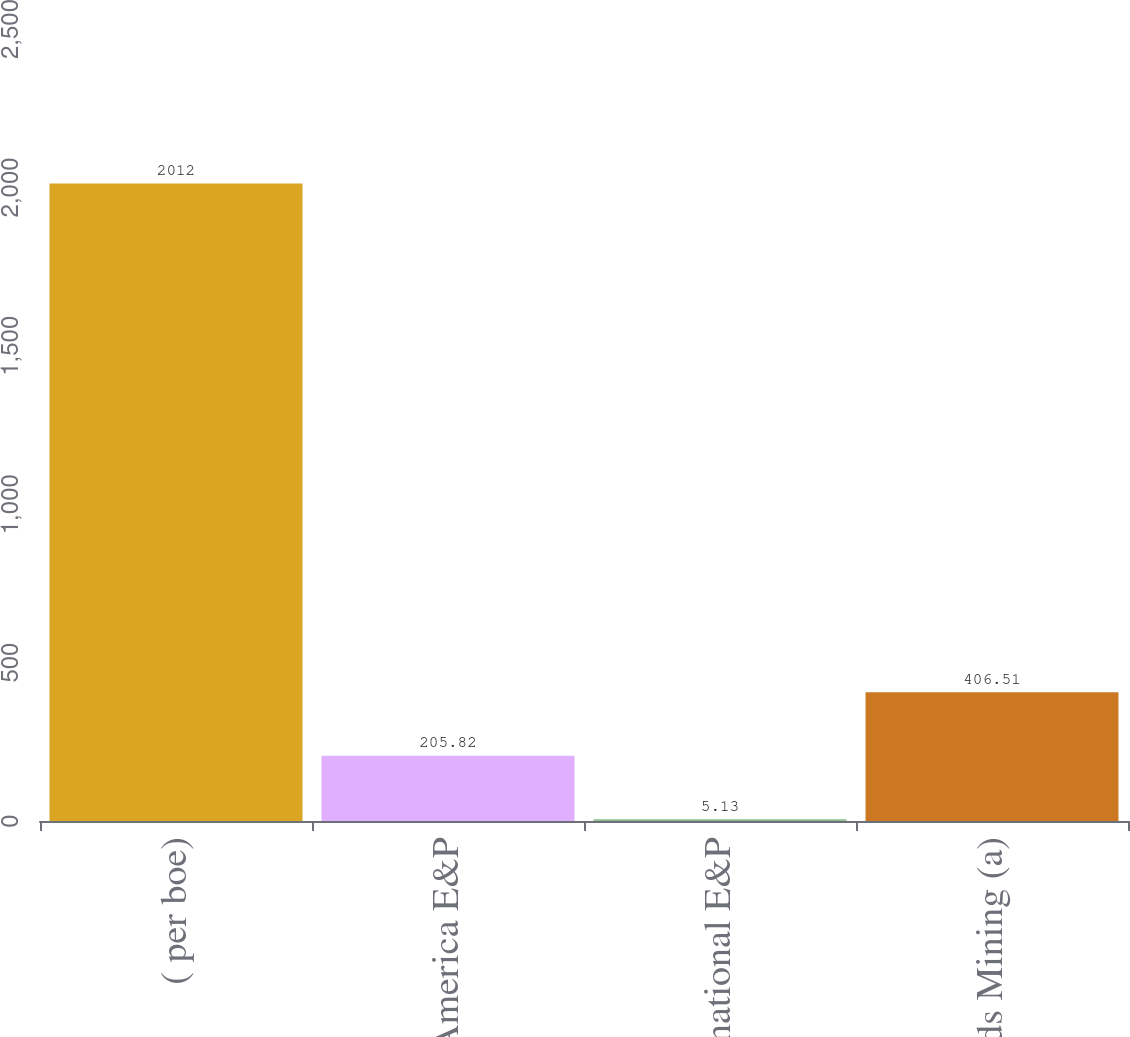<chart> <loc_0><loc_0><loc_500><loc_500><bar_chart><fcel>( per boe)<fcel>North America E&P<fcel>International E&P<fcel>Oil Sands Mining (a)<nl><fcel>2012<fcel>205.82<fcel>5.13<fcel>406.51<nl></chart> 